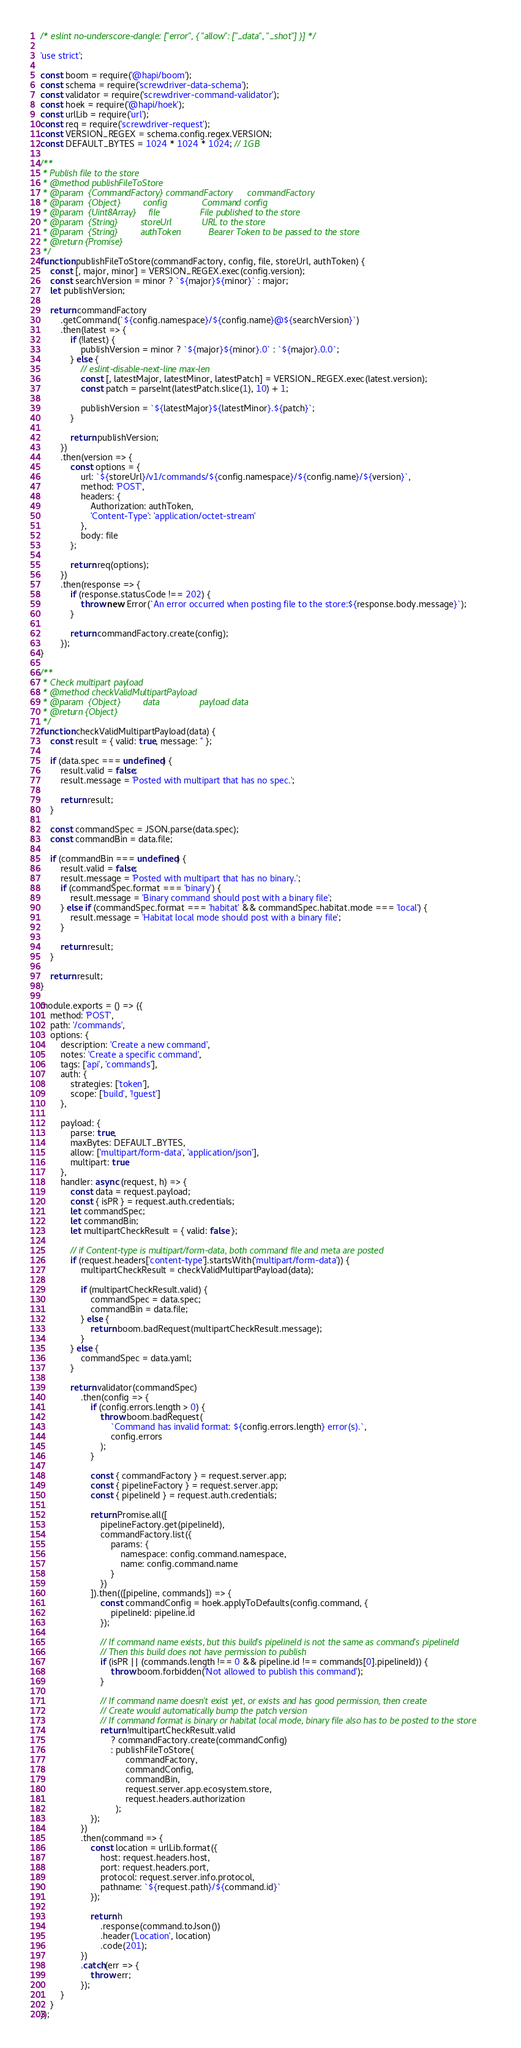<code> <loc_0><loc_0><loc_500><loc_500><_JavaScript_>/* eslint no-underscore-dangle: ["error", { "allow": ["_data", "_shot"] }] */

'use strict';

const boom = require('@hapi/boom');
const schema = require('screwdriver-data-schema');
const validator = require('screwdriver-command-validator');
const hoek = require('@hapi/hoek');
const urlLib = require('url');
const req = require('screwdriver-request');
const VERSION_REGEX = schema.config.regex.VERSION;
const DEFAULT_BYTES = 1024 * 1024 * 1024; // 1GB

/**
 * Publish file to the store
 * @method publishFileToStore
 * @param  {CommandFactory} commandFactory      commandFactory
 * @param  {Object}         config              Command config
 * @param  {Uint8Array}     file                File published to the store
 * @param  {String}         storeUrl            URL to the store
 * @param  {String}         authToken           Bearer Token to be passed to the store
 * @return {Promise}
 */
function publishFileToStore(commandFactory, config, file, storeUrl, authToken) {
    const [, major, minor] = VERSION_REGEX.exec(config.version);
    const searchVersion = minor ? `${major}${minor}` : major;
    let publishVersion;

    return commandFactory
        .getCommand(`${config.namespace}/${config.name}@${searchVersion}`)
        .then(latest => {
            if (!latest) {
                publishVersion = minor ? `${major}${minor}.0` : `${major}.0.0`;
            } else {
                // eslint-disable-next-line max-len
                const [, latestMajor, latestMinor, latestPatch] = VERSION_REGEX.exec(latest.version);
                const patch = parseInt(latestPatch.slice(1), 10) + 1;

                publishVersion = `${latestMajor}${latestMinor}.${patch}`;
            }

            return publishVersion;
        })
        .then(version => {
            const options = {
                url: `${storeUrl}/v1/commands/${config.namespace}/${config.name}/${version}`,
                method: 'POST',
                headers: {
                    Authorization: authToken,
                    'Content-Type': 'application/octet-stream'
                },
                body: file
            };

            return req(options);
        })
        .then(response => {
            if (response.statusCode !== 202) {
                throw new Error(`An error occurred when posting file to the store:${response.body.message}`);
            }

            return commandFactory.create(config);
        });
}

/**
 * Check multipart payload
 * @method checkValidMultipartPayload
 * @param  {Object}         data                payload data
 * @return {Object}
 */
function checkValidMultipartPayload(data) {
    const result = { valid: true, message: '' };

    if (data.spec === undefined) {
        result.valid = false;
        result.message = 'Posted with multipart that has no spec.';

        return result;
    }

    const commandSpec = JSON.parse(data.spec);
    const commandBin = data.file;

    if (commandBin === undefined) {
        result.valid = false;
        result.message = 'Posted with multipart that has no binary.';
        if (commandSpec.format === 'binary') {
            result.message = 'Binary command should post with a binary file';
        } else if (commandSpec.format === 'habitat' && commandSpec.habitat.mode === 'local') {
            result.message = 'Habitat local mode should post with a binary file';
        }

        return result;
    }

    return result;
}

module.exports = () => ({
    method: 'POST',
    path: '/commands',
    options: {
        description: 'Create a new command',
        notes: 'Create a specific command',
        tags: ['api', 'commands'],
        auth: {
            strategies: ['token'],
            scope: ['build', '!guest']
        },

        payload: {
            parse: true,
            maxBytes: DEFAULT_BYTES,
            allow: ['multipart/form-data', 'application/json'],
            multipart: true
        },
        handler: async (request, h) => {
            const data = request.payload;
            const { isPR } = request.auth.credentials;
            let commandSpec;
            let commandBin;
            let multipartCheckResult = { valid: false };

            // if Content-type is multipart/form-data, both command file and meta are posted
            if (request.headers['content-type'].startsWith('multipart/form-data')) {
                multipartCheckResult = checkValidMultipartPayload(data);

                if (multipartCheckResult.valid) {
                    commandSpec = data.spec;
                    commandBin = data.file;
                } else {
                    return boom.badRequest(multipartCheckResult.message);
                }
            } else {
                commandSpec = data.yaml;
            }

            return validator(commandSpec)
                .then(config => {
                    if (config.errors.length > 0) {
                        throw boom.badRequest(
                            `Command has invalid format: ${config.errors.length} error(s).`,
                            config.errors
                        );
                    }

                    const { commandFactory } = request.server.app;
                    const { pipelineFactory } = request.server.app;
                    const { pipelineId } = request.auth.credentials;

                    return Promise.all([
                        pipelineFactory.get(pipelineId),
                        commandFactory.list({
                            params: {
                                namespace: config.command.namespace,
                                name: config.command.name
                            }
                        })
                    ]).then(([pipeline, commands]) => {
                        const commandConfig = hoek.applyToDefaults(config.command, {
                            pipelineId: pipeline.id
                        });

                        // If command name exists, but this build's pipelineId is not the same as command's pipelineId
                        // Then this build does not have permission to publish
                        if (isPR || (commands.length !== 0 && pipeline.id !== commands[0].pipelineId)) {
                            throw boom.forbidden('Not allowed to publish this command');
                        }

                        // If command name doesn't exist yet, or exists and has good permission, then create
                        // Create would automatically bump the patch version
                        // If command format is binary or habitat local mode, binary file also has to be posted to the store
                        return !multipartCheckResult.valid
                            ? commandFactory.create(commandConfig)
                            : publishFileToStore(
                                  commandFactory,
                                  commandConfig,
                                  commandBin,
                                  request.server.app.ecosystem.store,
                                  request.headers.authorization
                              );
                    });
                })
                .then(command => {
                    const location = urlLib.format({
                        host: request.headers.host,
                        port: request.headers.port,
                        protocol: request.server.info.protocol,
                        pathname: `${request.path}/${command.id}`
                    });

                    return h
                        .response(command.toJson())
                        .header('Location', location)
                        .code(201);
                })
                .catch(err => {
                    throw err;
                });
        }
    }
});
</code> 